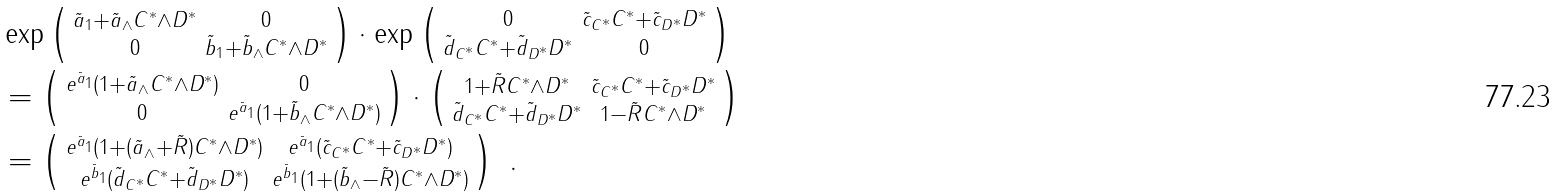Convert formula to latex. <formula><loc_0><loc_0><loc_500><loc_500>& \exp \left ( \begin{smallmatrix} \tilde { a } _ { 1 } + \tilde { a } _ { \wedge } C ^ { \ast } \wedge D ^ { \ast } & 0 \\ 0 & \tilde { b } _ { 1 } + \tilde { b } _ { \wedge } C ^ { \ast } \wedge D ^ { \ast } \end{smallmatrix} \right ) \cdot \exp \left ( \begin{smallmatrix} 0 & \tilde { c } _ { C ^ { \ast } } C ^ { \ast } + \tilde { c } _ { D ^ { \ast } } D ^ { \ast } \\ \tilde { d } _ { C ^ { \ast } } C ^ { \ast } + \tilde { d } _ { D ^ { \ast } } D ^ { \ast } & 0 \end{smallmatrix} \right ) \\ & = \left ( \begin{smallmatrix} e ^ { \tilde { a } _ { 1 } } ( 1 + \tilde { a } _ { \wedge } C ^ { \ast } \wedge D ^ { \ast } ) & 0 \\ 0 & e ^ { \tilde { a } _ { 1 } } ( 1 + \tilde { b } _ { \wedge } C ^ { \ast } \wedge D ^ { \ast } ) \end{smallmatrix} \right ) \cdot \left ( \begin{smallmatrix} 1 + \tilde { R } C ^ { \ast } \wedge D ^ { \ast } & \tilde { c } _ { C ^ { \ast } } C ^ { \ast } + \tilde { c } _ { D ^ { \ast } } D ^ { \ast } \\ \tilde { d } _ { C ^ { \ast } } C ^ { \ast } + \tilde { d } _ { D ^ { \ast } } D ^ { \ast } & 1 - \tilde { R } C ^ { \ast } \wedge D ^ { \ast } \end{smallmatrix} \right ) \\ & = \left ( \begin{smallmatrix} e ^ { \tilde { a } _ { 1 } } ( 1 + ( \tilde { a } _ { \wedge } + \tilde { R } ) C ^ { \ast } \wedge D ^ { \ast } ) & e ^ { \tilde { a } _ { 1 } } ( \tilde { c } _ { C ^ { \ast } } C ^ { \ast } + \tilde { c } _ { D ^ { \ast } } D ^ { \ast } ) \\ e ^ { \tilde { b } _ { 1 } } ( \tilde { d } _ { C ^ { \ast } } C ^ { \ast } + \tilde { d } _ { D ^ { \ast } } D ^ { \ast } ) & e ^ { \tilde { b } _ { 1 } } ( 1 + ( \tilde { b } _ { \wedge } - \tilde { R } ) C ^ { \ast } \wedge D ^ { \ast } ) \end{smallmatrix} \right ) \ .</formula> 